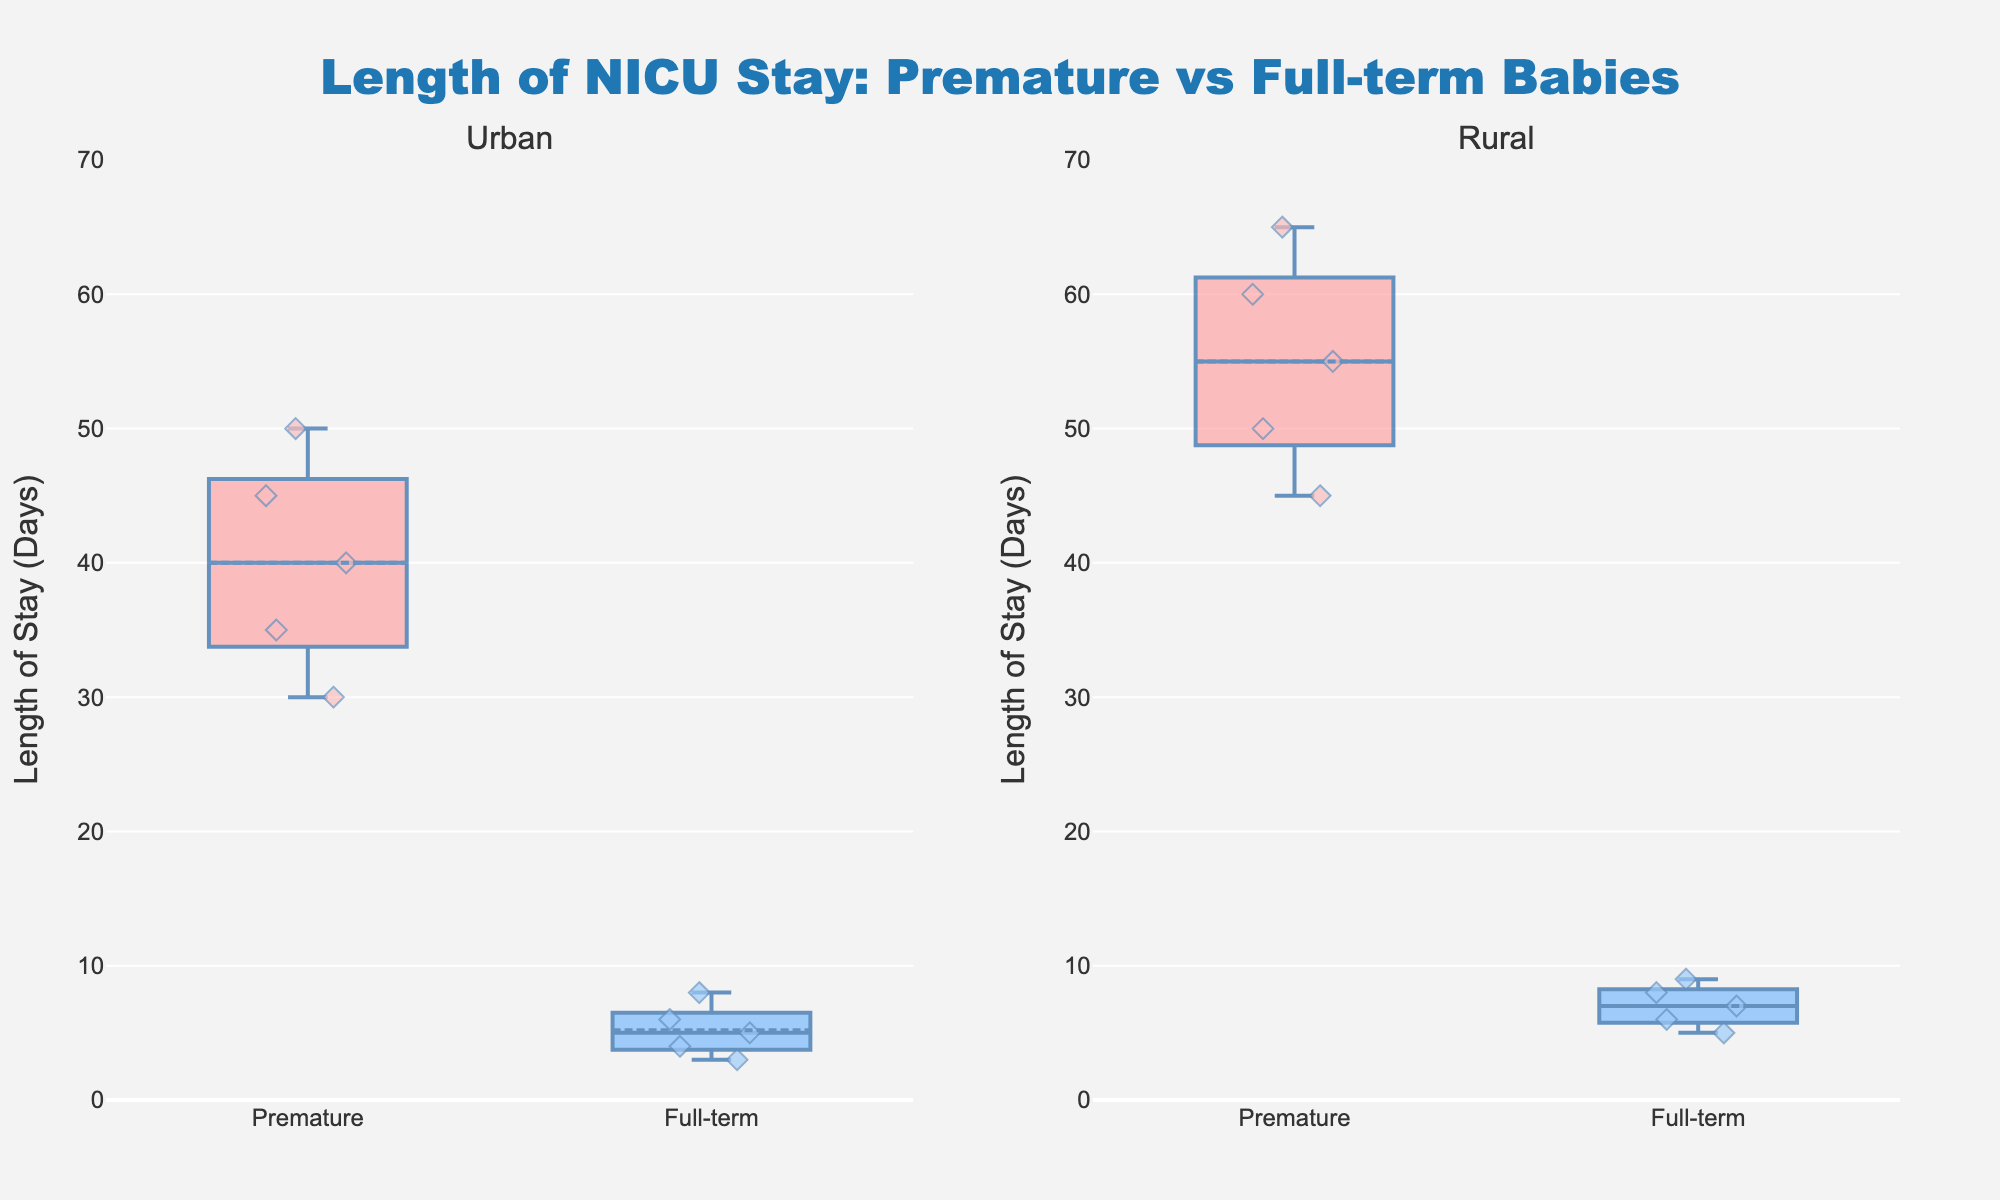What is the title of the plot? The title is located at the top of the plot and gives an overall description of what the figure is illustrating.
Answer: Length of NICU Stay: Premature vs Full-term Babies Which group has the longest median NICU stay in the rural area? Look at the middle line inside the box for each group in the rural subplot. The higher the line, the longer the median stay.
Answer: Premature How do the lengths of NICU stay for full-term babies compare between urban and rural areas? Observe the positions of the box plots for full-term babies in both urban and rural subplots. Compare the central tendency (median) and distribution (spread).
Answer: Rural stays are generally longer What is the interquartile range (IQR) for premature babies in the urban area? The IQR is the box's height, representing the middle 50% of the data. Subtract the lower quartile (bottom of the box) from the upper quartile (top of the box).
Answer: 15 days Are there any outliers in the NICU stay data for full-term babies in urban areas? Outliers are displayed as individual points outside the whiskers of the box plots.
Answer: No Which group shows the largest variability in NICU stay lengths in the rural area? Variability is indicated by the height of the boxes and the length of the whiskers. Identify which group has the most spread-out points.
Answer: Premature How does the average NICU stay for full-term babies compare between urban and rural areas? Two operations are needed: find the mean values depicted inside the boxes with the dashed lines, then compare those values.
Answer: Rural is higher In which area do premature babies have a higher median NICU stay? Look for the line within the box plot which indicates the median. Compare across urban and rural areas for premature babies.
Answer: Rural What do the colors signify in this plot? Colors provide a way to differentiate between conditions, with each color representing one of two categories. Look at the color legend or labels associated with the colors.
Answer: Red for Premature, Blue for Full-term 